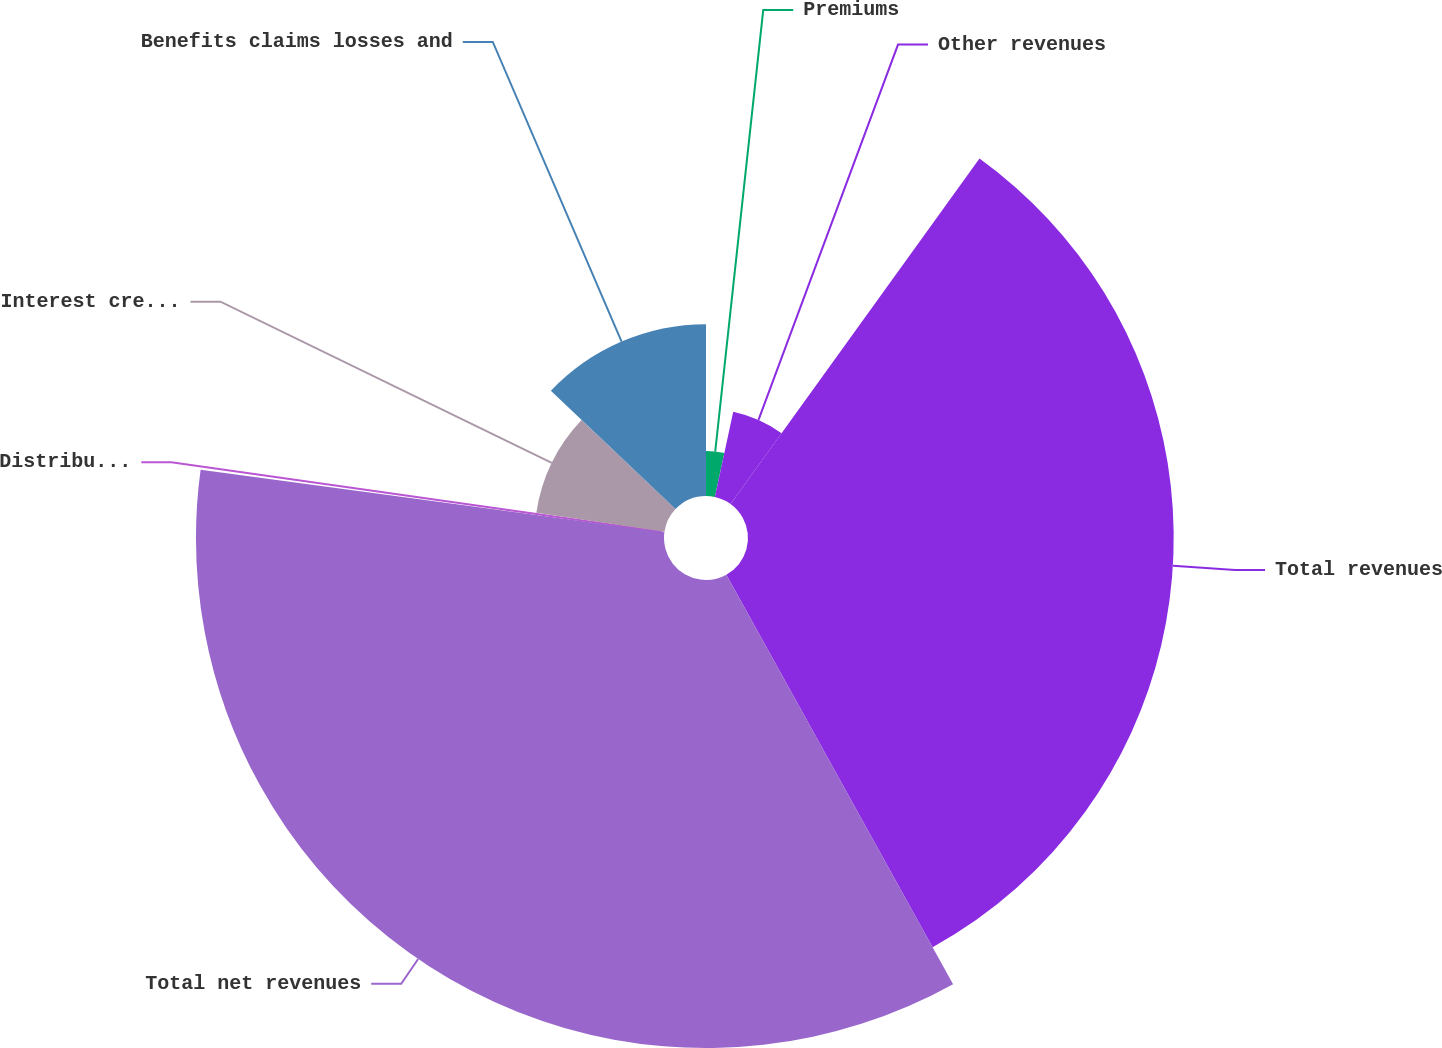<chart> <loc_0><loc_0><loc_500><loc_500><pie_chart><fcel>Premiums<fcel>Other revenues<fcel>Total revenues<fcel>Total net revenues<fcel>Distribution expenses<fcel>Interest credited to fixed<fcel>Benefits claims losses and<nl><fcel>3.38%<fcel>6.56%<fcel>32.01%<fcel>35.19%<fcel>0.2%<fcel>9.74%<fcel>12.92%<nl></chart> 